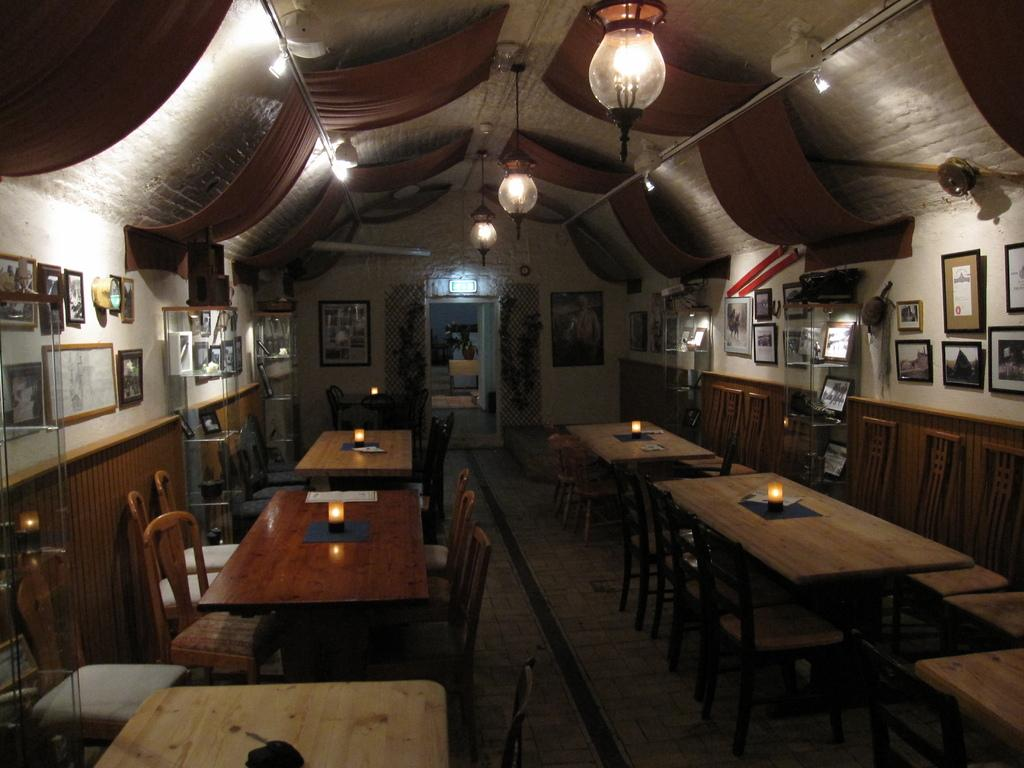What type of furniture is present in the image? There are tables and chairs in the image. What type of lighting is present in the image? There are candles and lights in the image. What type of access point is present in the image? There is a door in the image. What type of decorative items are present in the image? There are photo frames in the image. What type of architectural feature is present in the image? There is a wall in the image. How many birds can be seen in the image? There are no birds present in the image. 